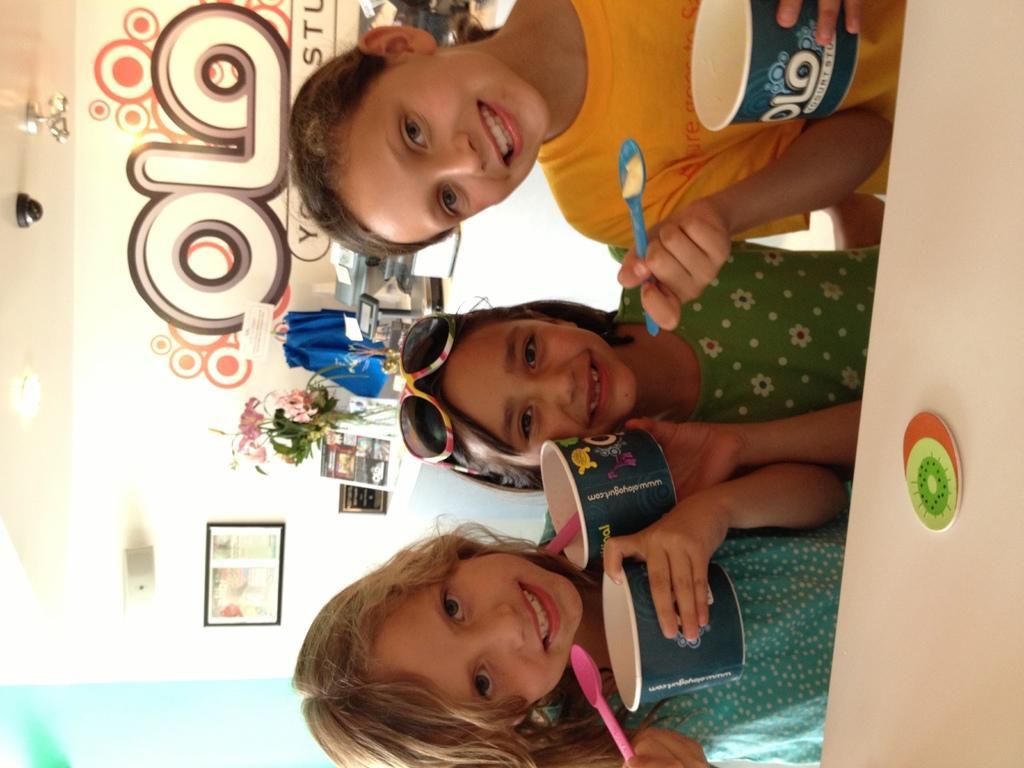Please provide a concise description of this image. In this image, we can see three children are holding cups. They are seeing and smiling. Background there is a wall, frame, flowers with flower vase, few objects. 